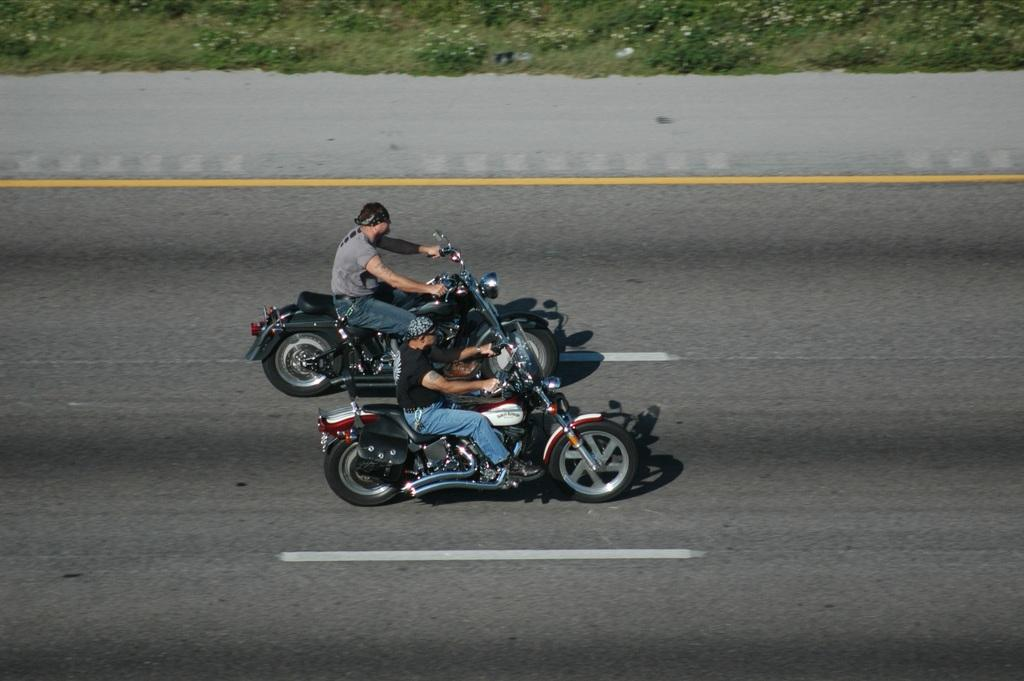How many people are in the image? There are 2 men in the image. What are the men doing in the image? The men are on a bike. Where is the bike located in the image? The bike is on the road. What type of vegetation can be seen in the image? There are plants and grass in the image. What type of loaf is being used as a prop in the image? There is no loaf present in the image. Who is the actor in the image? The image does not depict a performance or an actor. 